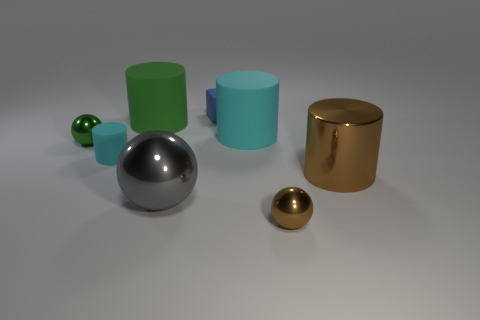The small brown thing has what shape?
Provide a short and direct response. Sphere. What is the material of the small ball in front of the small green shiny thing that is in front of the big cylinder behind the big cyan matte cylinder?
Your answer should be very brief. Metal. There is another cylinder that is the same color as the tiny rubber cylinder; what is it made of?
Your answer should be very brief. Rubber. What number of objects are large brown metal cubes or brown shiny cylinders?
Keep it short and to the point. 1. Are the small object that is right of the small blue matte block and the small cyan cylinder made of the same material?
Your answer should be very brief. No. How many objects are small rubber objects in front of the blue matte object or blue blocks?
Make the answer very short. 2. The other tiny thing that is made of the same material as the blue thing is what color?
Your answer should be compact. Cyan. Is there a brown metallic ball of the same size as the green matte cylinder?
Provide a succinct answer. No. Is the color of the large object in front of the shiny cylinder the same as the tiny rubber cylinder?
Ensure brevity in your answer.  No. There is a tiny object that is to the right of the tiny cyan object and in front of the big cyan cylinder; what color is it?
Make the answer very short. Brown. 